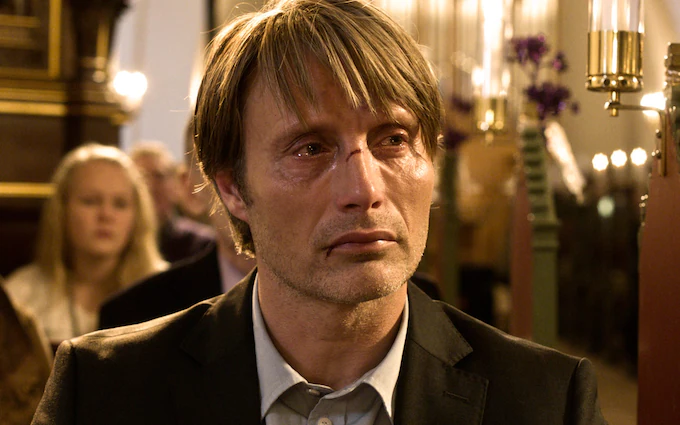What could be the possible reason for this man's somber expression in the church setting? The man's somber expression, accompanied by the church setting, suggests he might be attending a solemn occasion such as a memorial service or a moment of personal reflection. His attire and the ambiance point to a moment of significant emotional weight, deeply personal or communal. 